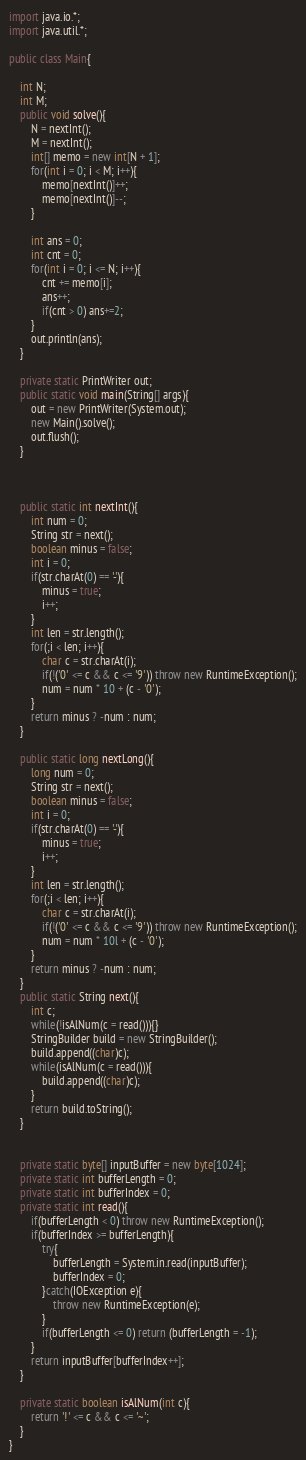Convert code to text. <code><loc_0><loc_0><loc_500><loc_500><_Java_>import java.io.*;
import java.util.*;
 
public class Main{
	
	int N;
	int M;
	public void solve(){
		N = nextInt();
		M = nextInt();
		int[] memo = new int[N + 1];
		for(int i = 0; i < M; i++){
			memo[nextInt()]++;
			memo[nextInt()]--;
		}
		
		int ans = 0;
		int cnt = 0;
		for(int i = 0; i <= N; i++){
			cnt += memo[i];
			ans++;
			if(cnt > 0) ans+=2;
		}
		out.println(ans);
	}
	
	private static PrintWriter out;
	public static void main(String[] args){
		out = new PrintWriter(System.out);
		new Main().solve();
		out.flush();
	}
	
	
	
	public static int nextInt(){
		int num = 0;
		String str = next();
		boolean minus = false;
		int i = 0;
		if(str.charAt(0) == '-'){
			minus = true;
			i++;
		}
		int len = str.length();
		for(;i < len; i++){
			char c = str.charAt(i);
			if(!('0' <= c && c <= '9')) throw new RuntimeException();
			num = num * 10 + (c - '0');
		}
		return minus ? -num : num;
	}
	
	public static long nextLong(){
		long num = 0;
		String str = next();
		boolean minus = false;
		int i = 0;
		if(str.charAt(0) == '-'){
			minus = true;
			i++;
		}
		int len = str.length();
		for(;i < len; i++){
			char c = str.charAt(i);
			if(!('0' <= c && c <= '9')) throw new RuntimeException();
			num = num * 10l + (c - '0');
		}
		return minus ? -num : num;
	}
	public static String next(){
		int c;
		while(!isAlNum(c = read())){}
		StringBuilder build = new StringBuilder();
		build.append((char)c);
		while(isAlNum(c = read())){
			build.append((char)c);
		}
		return build.toString();
	}
	
	
	private static byte[] inputBuffer = new byte[1024];
	private static int bufferLength = 0;
	private static int bufferIndex = 0;
	private static int read(){
		if(bufferLength < 0) throw new RuntimeException();
		if(bufferIndex >= bufferLength){
			try{
				bufferLength = System.in.read(inputBuffer);
				bufferIndex = 0;
			}catch(IOException e){
				throw new RuntimeException(e);
			}
			if(bufferLength <= 0) return (bufferLength = -1);
		}
		return inputBuffer[bufferIndex++];
	}
	
	private static boolean isAlNum(int c){
		return '!' <= c && c <= '~';
	}
}</code> 